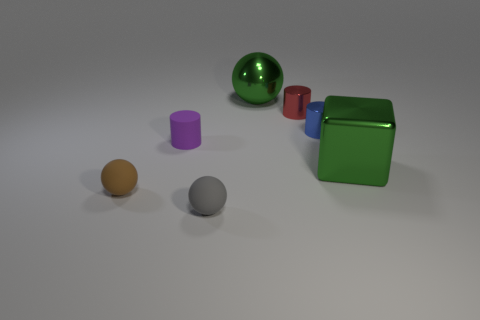How many other objects are there of the same material as the tiny red cylinder?
Your answer should be compact. 3. What number of objects are large things behind the small matte cylinder or large green things on the right side of the tiny blue metal cylinder?
Ensure brevity in your answer.  2. Do the big metal thing that is in front of the tiny blue thing and the large shiny object that is behind the rubber cylinder have the same shape?
Your response must be concise. No. There is a gray thing that is the same size as the purple cylinder; what is its shape?
Provide a succinct answer. Sphere. How many shiny objects are either tiny red cylinders or large green cubes?
Provide a short and direct response. 2. Do the sphere that is in front of the brown sphere and the sphere that is behind the purple rubber thing have the same material?
Keep it short and to the point. No. The tiny cylinder that is the same material as the brown object is what color?
Offer a terse response. Purple. Is the number of small rubber cylinders that are to the right of the blue shiny thing greater than the number of small red cylinders that are in front of the gray rubber object?
Your response must be concise. No. Are any objects visible?
Ensure brevity in your answer.  Yes. There is a large thing that is the same color as the metallic ball; what material is it?
Give a very brief answer. Metal. 